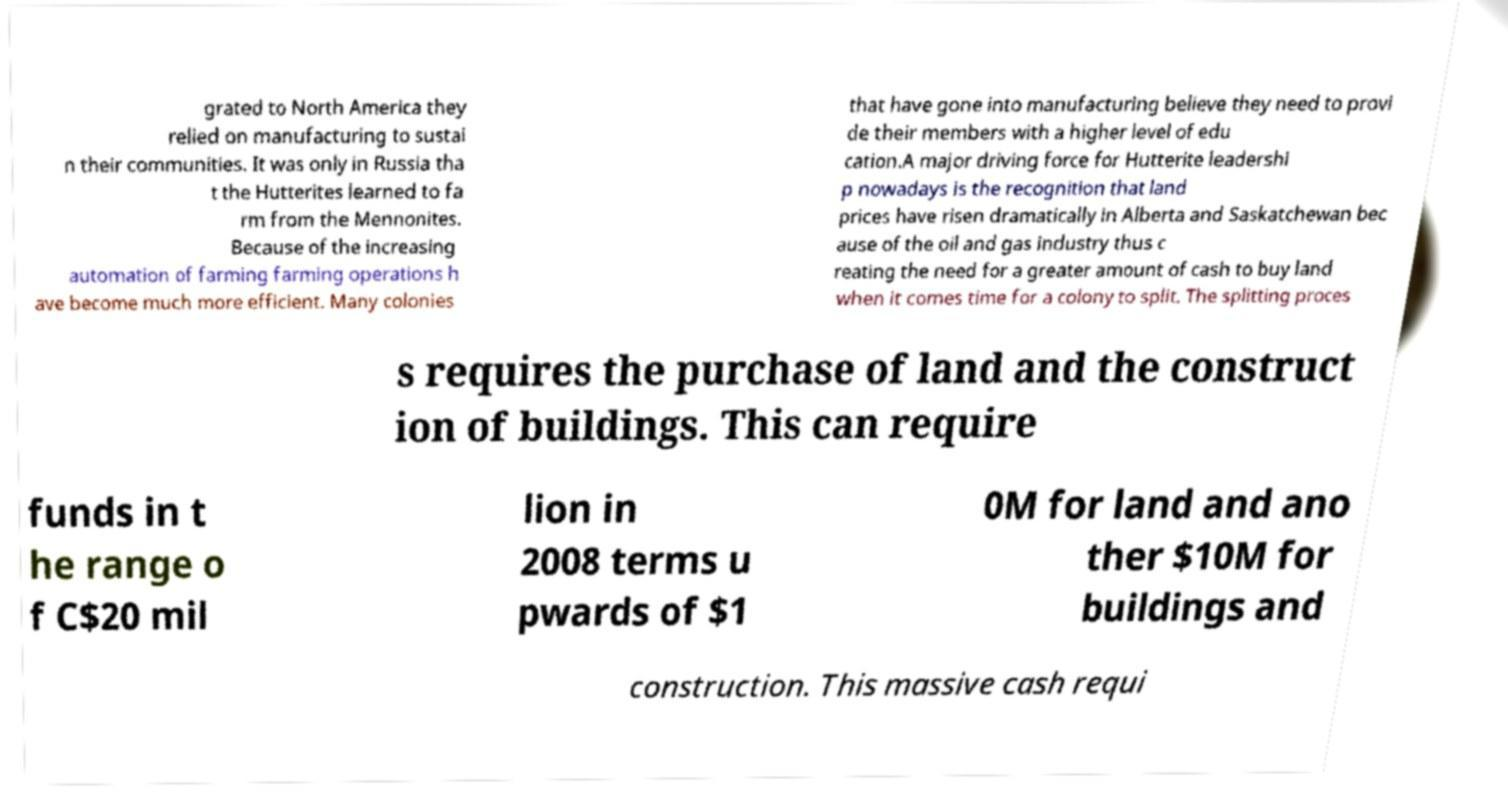What messages or text are displayed in this image? I need them in a readable, typed format. grated to North America they relied on manufacturing to sustai n their communities. It was only in Russia tha t the Hutterites learned to fa rm from the Mennonites. Because of the increasing automation of farming farming operations h ave become much more efficient. Many colonies that have gone into manufacturing believe they need to provi de their members with a higher level of edu cation.A major driving force for Hutterite leadershi p nowadays is the recognition that land prices have risen dramatically in Alberta and Saskatchewan bec ause of the oil and gas industry thus c reating the need for a greater amount of cash to buy land when it comes time for a colony to split. The splitting proces s requires the purchase of land and the construct ion of buildings. This can require funds in t he range o f C$20 mil lion in 2008 terms u pwards of $1 0M for land and ano ther $10M for buildings and construction. This massive cash requi 